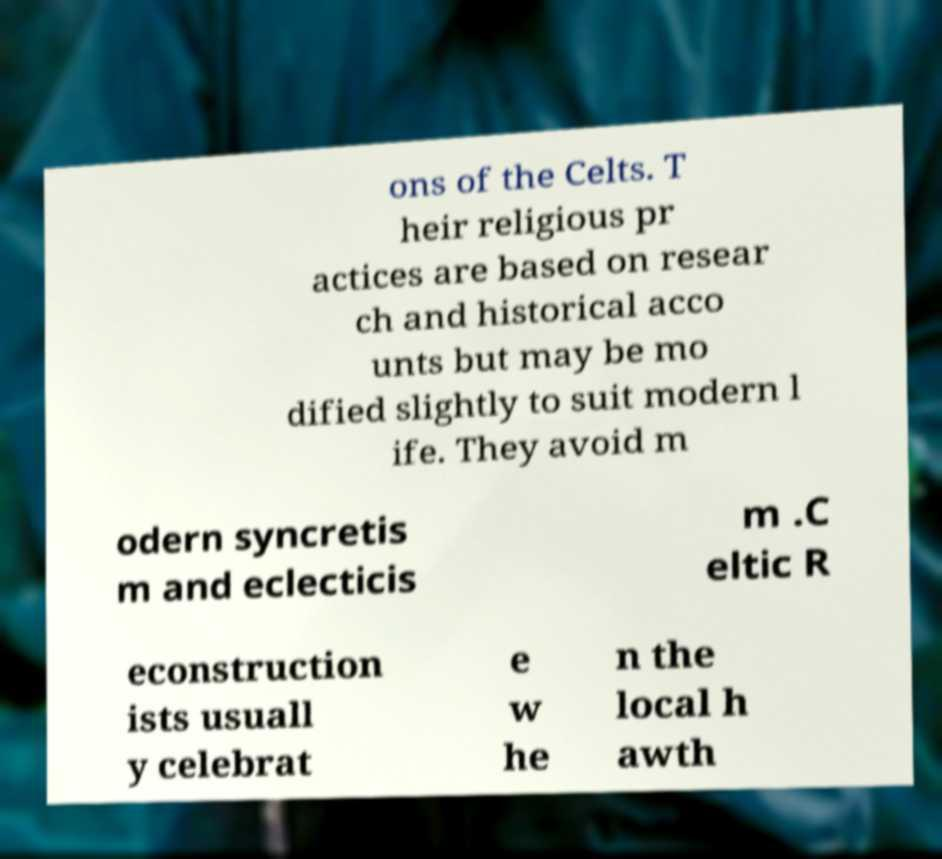Please identify and transcribe the text found in this image. ons of the Celts. T heir religious pr actices are based on resear ch and historical acco unts but may be mo dified slightly to suit modern l ife. They avoid m odern syncretis m and eclecticis m .C eltic R econstruction ists usuall y celebrat e w he n the local h awth 